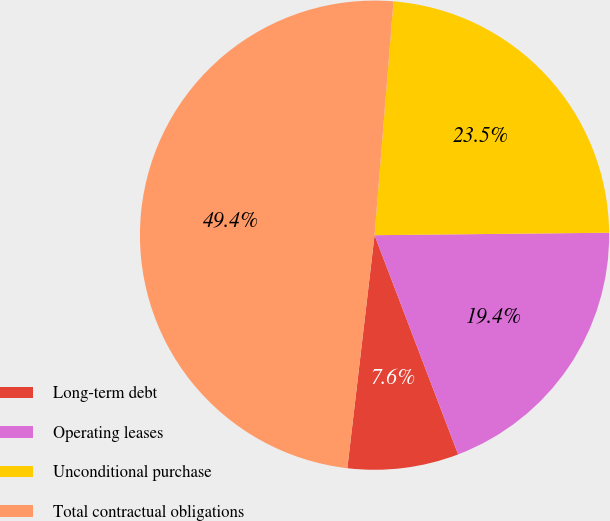<chart> <loc_0><loc_0><loc_500><loc_500><pie_chart><fcel>Long-term debt<fcel>Operating leases<fcel>Unconditional purchase<fcel>Total contractual obligations<nl><fcel>7.65%<fcel>19.37%<fcel>23.55%<fcel>49.44%<nl></chart> 